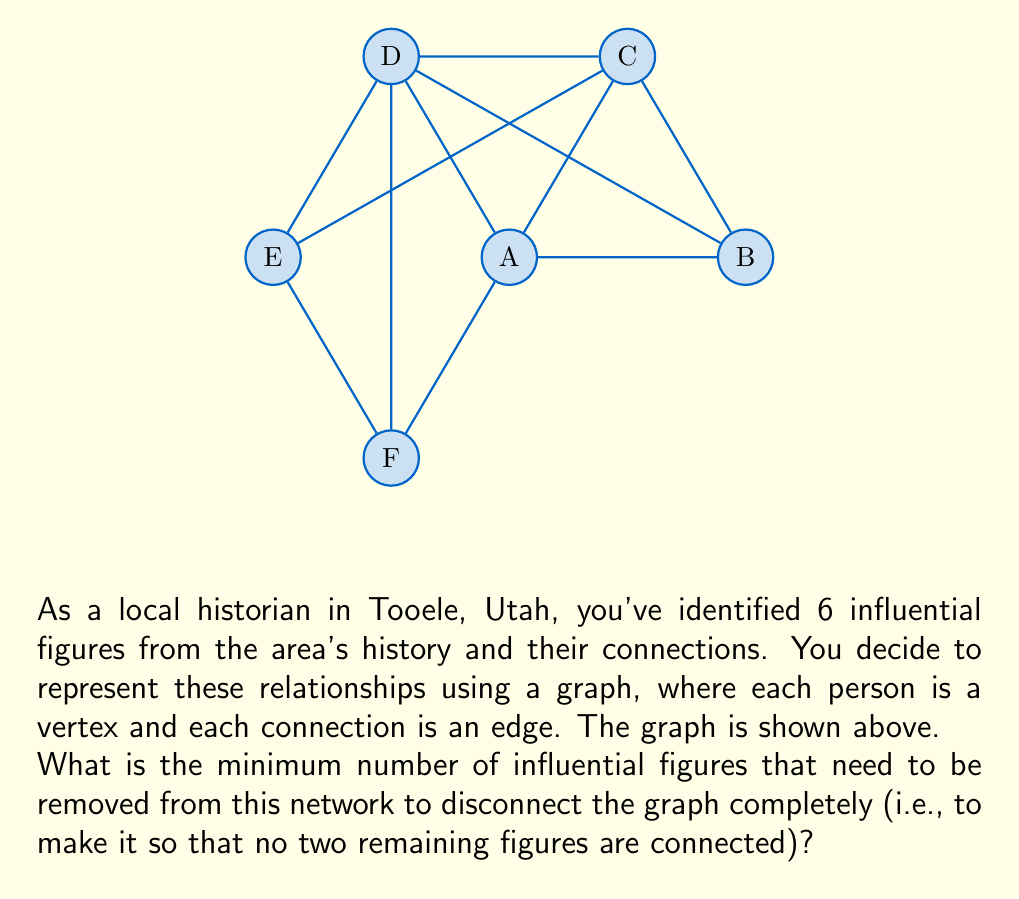Show me your answer to this math problem. To solve this problem, we need to find the vertex connectivity of the graph. The vertex connectivity is the minimum number of vertices that need to be removed to disconnect the graph.

Let's approach this step-by-step:

1) First, observe that the graph is not complete (not every vertex is connected to every other vertex), so the vertex connectivity will be less than 5 (n-1, where n is the number of vertices).

2) We can see that removing any single vertex will not disconnect the graph, so the vertex connectivity is at least 2.

3) Now, let's try removing two vertices:
   - If we remove A and D, the graph becomes disconnected into two components: {B,C} and {E,F}.
   - This is the minimum number of vertices we need to remove to disconnect the graph.

4) We can verify this by checking that removing any other pair of vertices will not disconnect the graph completely.

5) Therefore, the vertex connectivity of this graph is 2.

In terms of the historical context, this means that there are two key figures in this network whose removal would completely fragment the connections between the remaining influential people in Tooele's history.
Answer: 2 